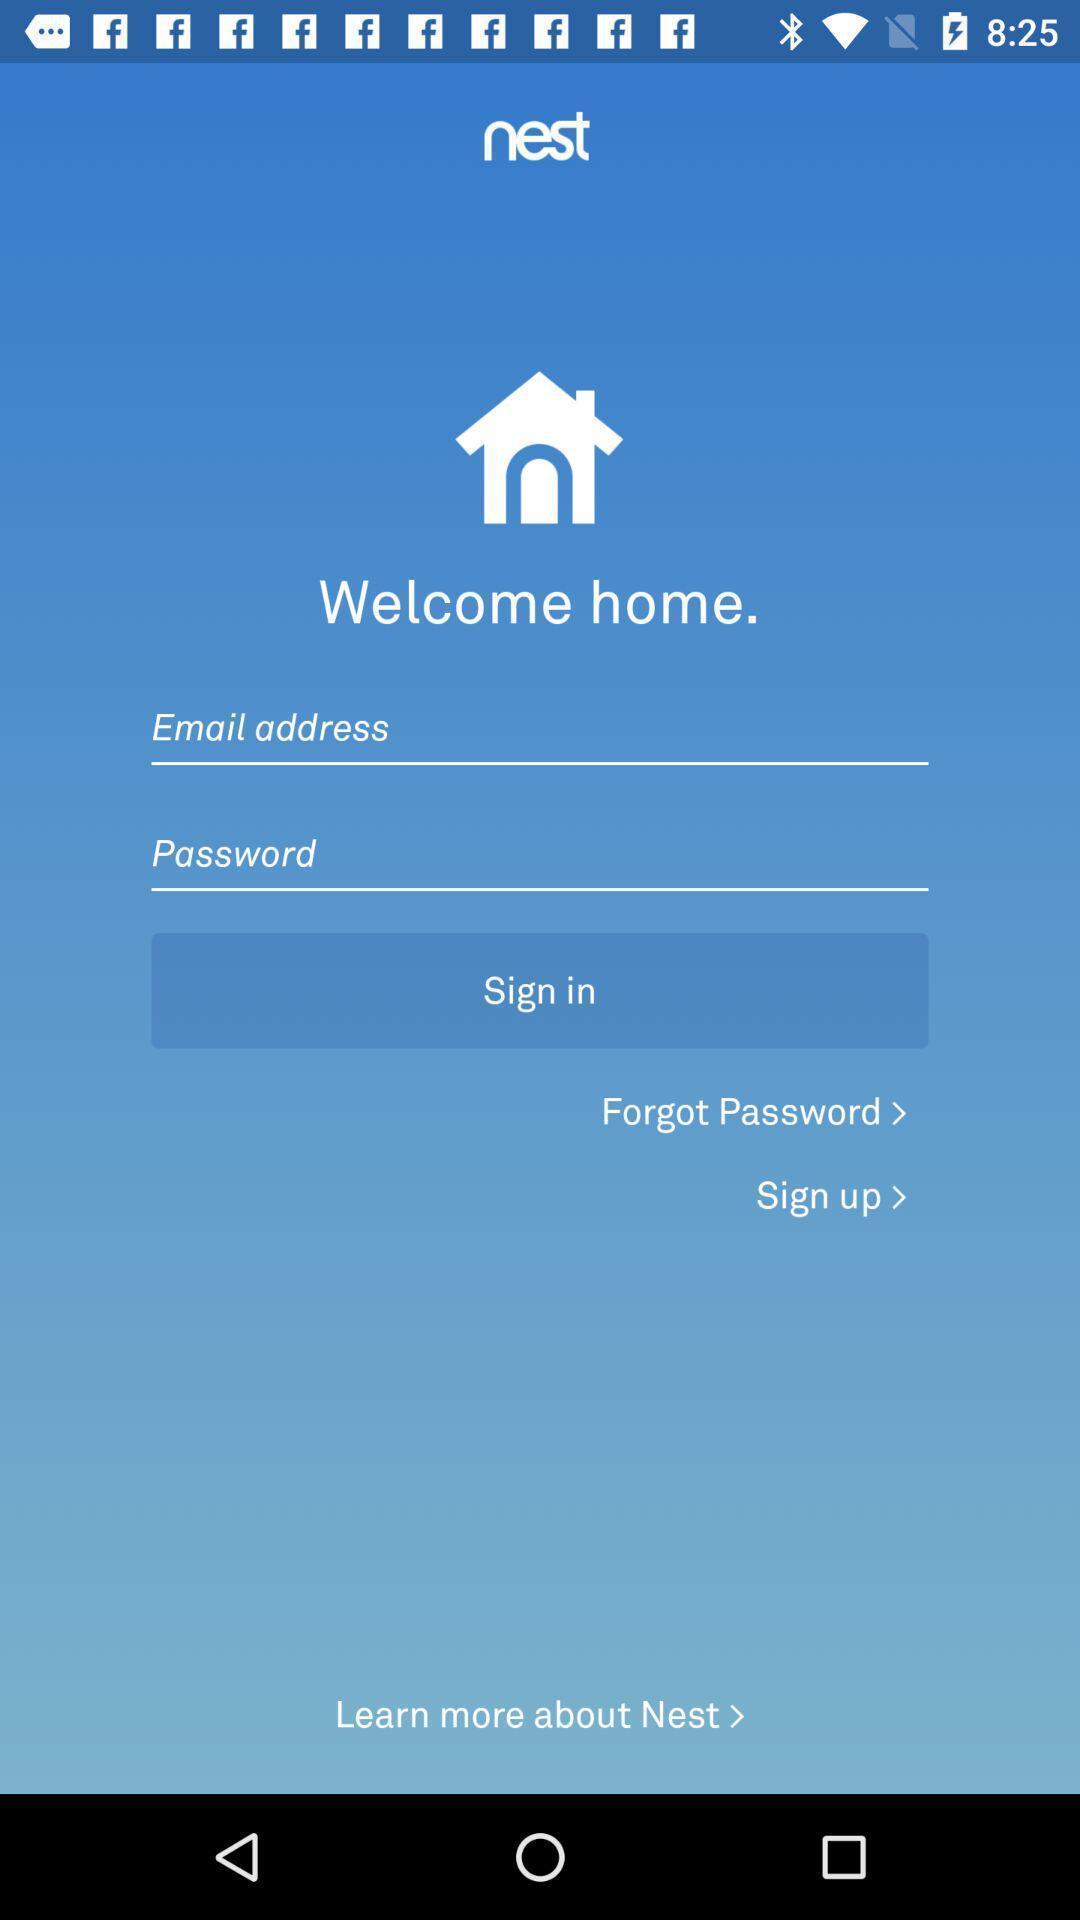What can you discern from this picture? Welcome page. 